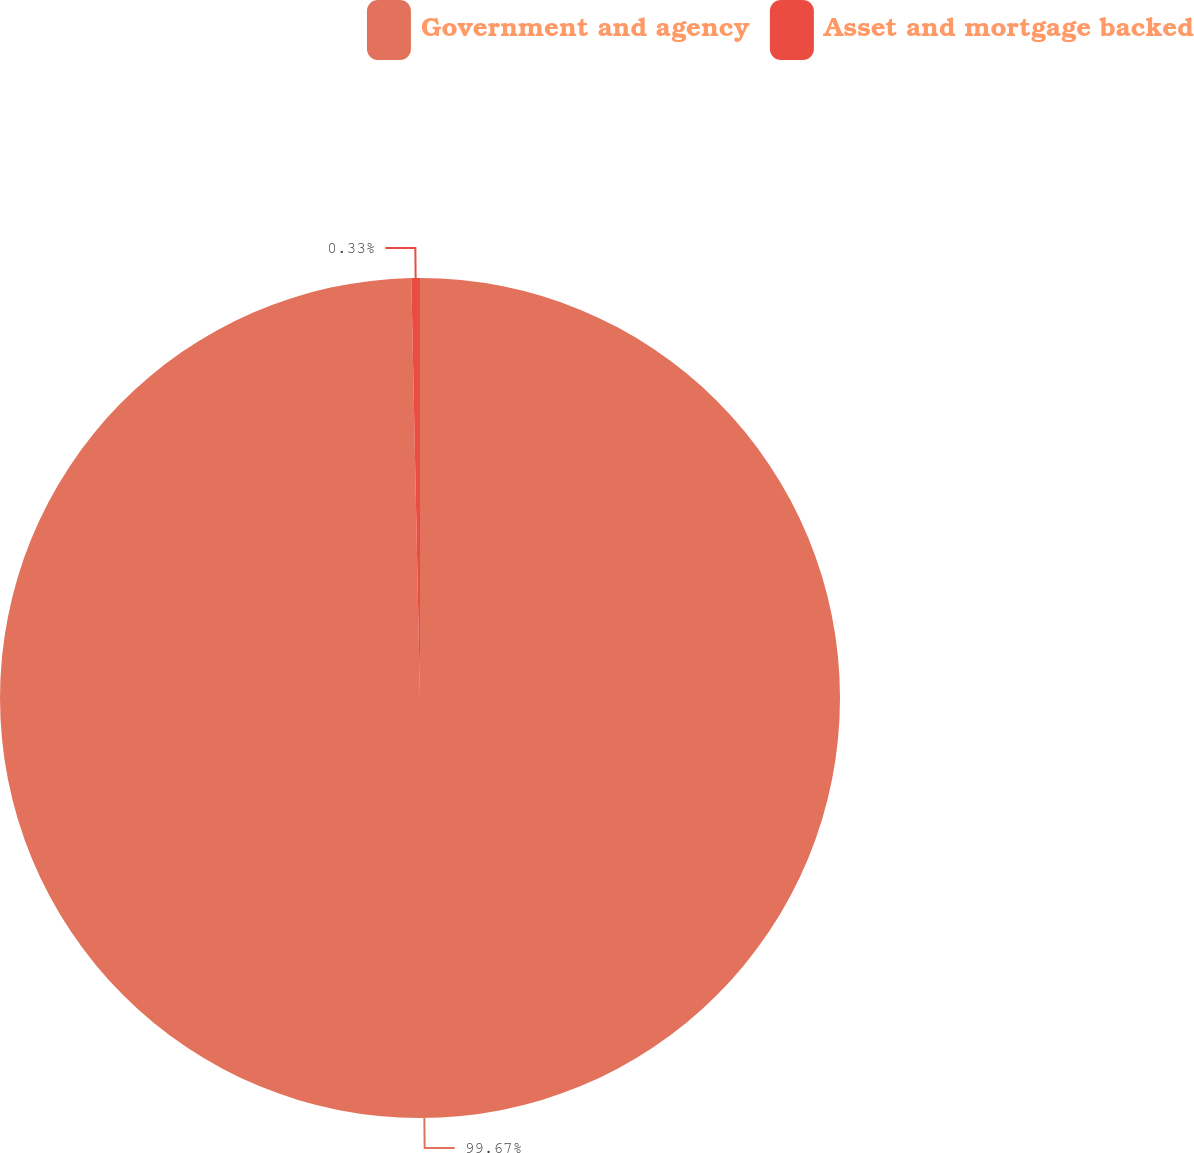Convert chart. <chart><loc_0><loc_0><loc_500><loc_500><pie_chart><fcel>Government and agency<fcel>Asset and mortgage backed<nl><fcel>99.67%<fcel>0.33%<nl></chart> 